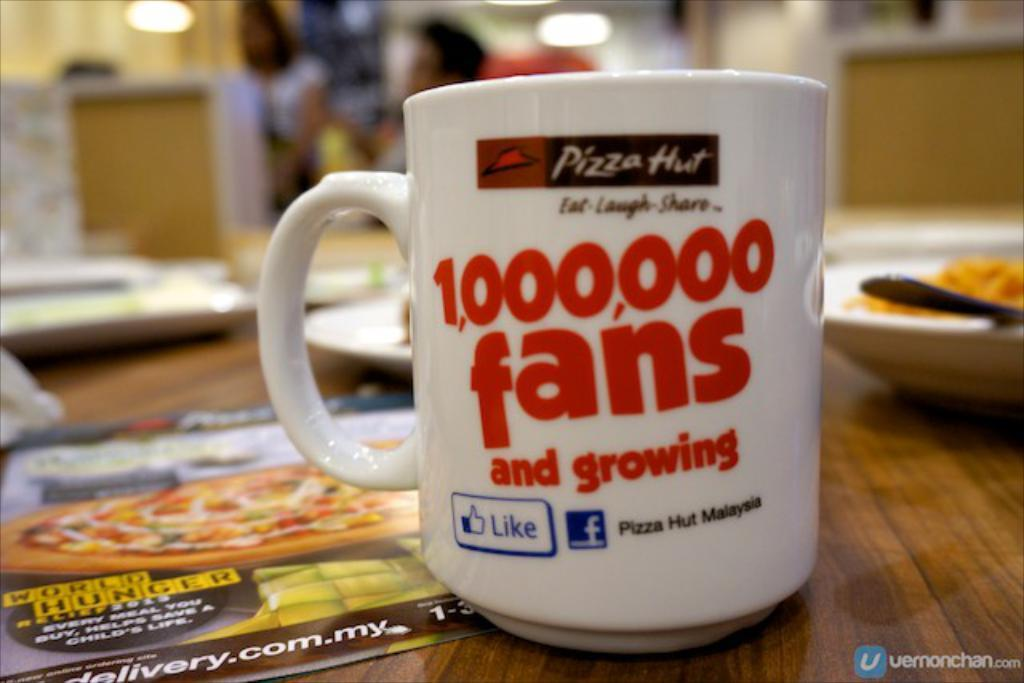<image>
Give a short and clear explanation of the subsequent image. A mug on a Pizza Hut table that says 1,000,000 fans and growing. 